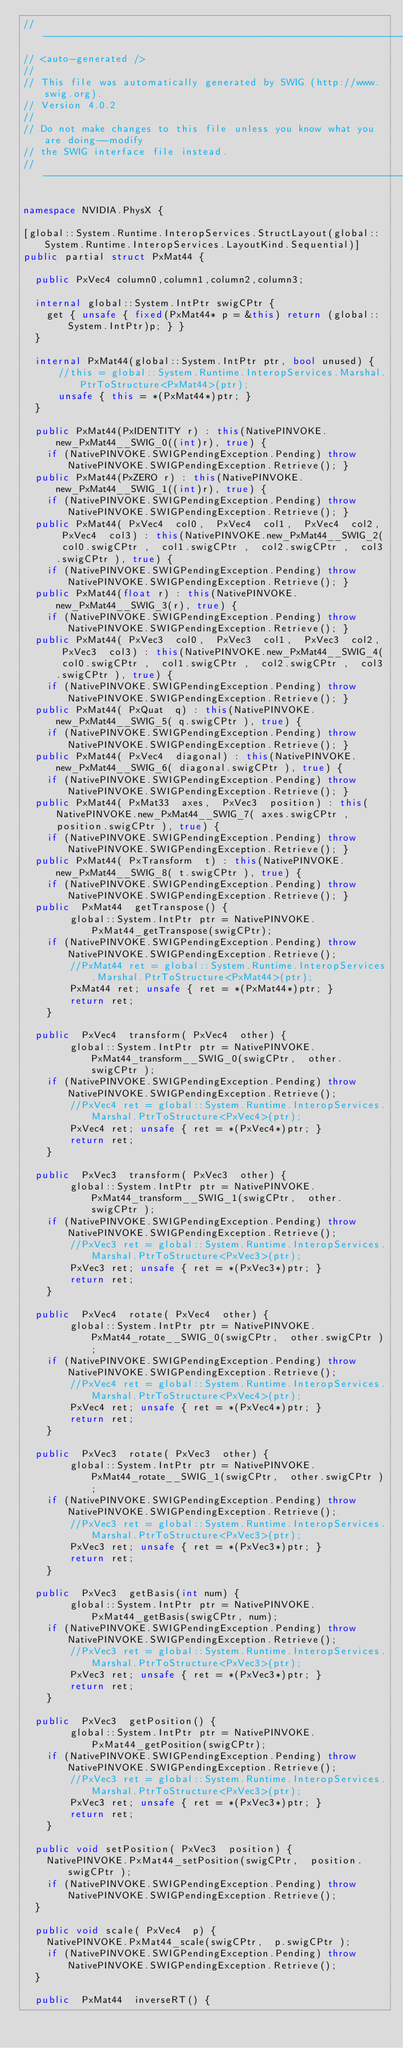<code> <loc_0><loc_0><loc_500><loc_500><_C#_>//------------------------------------------------------------------------------
// <auto-generated />
//
// This file was automatically generated by SWIG (http://www.swig.org).
// Version 4.0.2
//
// Do not make changes to this file unless you know what you are doing--modify
// the SWIG interface file instead.
//------------------------------------------------------------------------------

namespace NVIDIA.PhysX {

[global::System.Runtime.InteropServices.StructLayout(global::System.Runtime.InteropServices.LayoutKind.Sequential)]
public partial struct PxMat44 {

  public PxVec4 column0,column1,column2,column3;

  internal global::System.IntPtr swigCPtr {
    get { unsafe { fixed(PxMat44* p = &this) return (global::System.IntPtr)p; } }
  }

  internal PxMat44(global::System.IntPtr ptr, bool unused) {
      //this = global::System.Runtime.InteropServices.Marshal.PtrToStructure<PxMat44>(ptr);
      unsafe { this = *(PxMat44*)ptr; }
  }
    
  public PxMat44(PxIDENTITY r) : this(NativePINVOKE.new_PxMat44__SWIG_0((int)r), true) { 
    if (NativePINVOKE.SWIGPendingException.Pending) throw NativePINVOKE.SWIGPendingException.Retrieve(); }
  public PxMat44(PxZERO r) : this(NativePINVOKE.new_PxMat44__SWIG_1((int)r), true) { 
    if (NativePINVOKE.SWIGPendingException.Pending) throw NativePINVOKE.SWIGPendingException.Retrieve(); }
  public PxMat44( PxVec4  col0,  PxVec4  col1,  PxVec4  col2,  PxVec4  col3) : this(NativePINVOKE.new_PxMat44__SWIG_2( col0.swigCPtr ,  col1.swigCPtr ,  col2.swigCPtr ,  col3.swigCPtr ), true) { 
    if (NativePINVOKE.SWIGPendingException.Pending) throw NativePINVOKE.SWIGPendingException.Retrieve(); }
  public PxMat44(float r) : this(NativePINVOKE.new_PxMat44__SWIG_3(r), true) { 
    if (NativePINVOKE.SWIGPendingException.Pending) throw NativePINVOKE.SWIGPendingException.Retrieve(); }
  public PxMat44( PxVec3  col0,  PxVec3  col1,  PxVec3  col2,  PxVec3  col3) : this(NativePINVOKE.new_PxMat44__SWIG_4( col0.swigCPtr ,  col1.swigCPtr ,  col2.swigCPtr ,  col3.swigCPtr ), true) { 
    if (NativePINVOKE.SWIGPendingException.Pending) throw NativePINVOKE.SWIGPendingException.Retrieve(); }
  public PxMat44( PxQuat  q) : this(NativePINVOKE.new_PxMat44__SWIG_5( q.swigCPtr ), true) { 
    if (NativePINVOKE.SWIGPendingException.Pending) throw NativePINVOKE.SWIGPendingException.Retrieve(); }
  public PxMat44( PxVec4  diagonal) : this(NativePINVOKE.new_PxMat44__SWIG_6( diagonal.swigCPtr ), true) { 
    if (NativePINVOKE.SWIGPendingException.Pending) throw NativePINVOKE.SWIGPendingException.Retrieve(); }
  public PxMat44( PxMat33  axes,  PxVec3  position) : this(NativePINVOKE.new_PxMat44__SWIG_7( axes.swigCPtr ,  position.swigCPtr ), true) { 
    if (NativePINVOKE.SWIGPendingException.Pending) throw NativePINVOKE.SWIGPendingException.Retrieve(); }
  public PxMat44( PxTransform  t) : this(NativePINVOKE.new_PxMat44__SWIG_8( t.swigCPtr ), true) { 
    if (NativePINVOKE.SWIGPendingException.Pending) throw NativePINVOKE.SWIGPendingException.Retrieve(); }
  public  PxMat44  getTranspose() {
        global::System.IntPtr ptr = NativePINVOKE.PxMat44_getTranspose(swigCPtr);
    if (NativePINVOKE.SWIGPendingException.Pending) throw NativePINVOKE.SWIGPendingException.Retrieve();
        //PxMat44 ret = global::System.Runtime.InteropServices.Marshal.PtrToStructure<PxMat44>(ptr);
        PxMat44 ret; unsafe { ret = *(PxMat44*)ptr; }
        return ret;
    }

  public  PxVec4  transform( PxVec4  other) {
        global::System.IntPtr ptr = NativePINVOKE.PxMat44_transform__SWIG_0(swigCPtr,  other.swigCPtr );
    if (NativePINVOKE.SWIGPendingException.Pending) throw NativePINVOKE.SWIGPendingException.Retrieve();
        //PxVec4 ret = global::System.Runtime.InteropServices.Marshal.PtrToStructure<PxVec4>(ptr);
        PxVec4 ret; unsafe { ret = *(PxVec4*)ptr; }
        return ret;
    }

  public  PxVec3  transform( PxVec3  other) {
        global::System.IntPtr ptr = NativePINVOKE.PxMat44_transform__SWIG_1(swigCPtr,  other.swigCPtr );
    if (NativePINVOKE.SWIGPendingException.Pending) throw NativePINVOKE.SWIGPendingException.Retrieve();
        //PxVec3 ret = global::System.Runtime.InteropServices.Marshal.PtrToStructure<PxVec3>(ptr);
        PxVec3 ret; unsafe { ret = *(PxVec3*)ptr; }
        return ret;
    }

  public  PxVec4  rotate( PxVec4  other) {
        global::System.IntPtr ptr = NativePINVOKE.PxMat44_rotate__SWIG_0(swigCPtr,  other.swigCPtr );
    if (NativePINVOKE.SWIGPendingException.Pending) throw NativePINVOKE.SWIGPendingException.Retrieve();
        //PxVec4 ret = global::System.Runtime.InteropServices.Marshal.PtrToStructure<PxVec4>(ptr);
        PxVec4 ret; unsafe { ret = *(PxVec4*)ptr; }
        return ret;
    }

  public  PxVec3  rotate( PxVec3  other) {
        global::System.IntPtr ptr = NativePINVOKE.PxMat44_rotate__SWIG_1(swigCPtr,  other.swigCPtr );
    if (NativePINVOKE.SWIGPendingException.Pending) throw NativePINVOKE.SWIGPendingException.Retrieve();
        //PxVec3 ret = global::System.Runtime.InteropServices.Marshal.PtrToStructure<PxVec3>(ptr);
        PxVec3 ret; unsafe { ret = *(PxVec3*)ptr; }
        return ret;
    }

  public  PxVec3  getBasis(int num) {
        global::System.IntPtr ptr = NativePINVOKE.PxMat44_getBasis(swigCPtr, num);
    if (NativePINVOKE.SWIGPendingException.Pending) throw NativePINVOKE.SWIGPendingException.Retrieve();
        //PxVec3 ret = global::System.Runtime.InteropServices.Marshal.PtrToStructure<PxVec3>(ptr);
        PxVec3 ret; unsafe { ret = *(PxVec3*)ptr; }
        return ret;
    }

  public  PxVec3  getPosition() {
        global::System.IntPtr ptr = NativePINVOKE.PxMat44_getPosition(swigCPtr);
    if (NativePINVOKE.SWIGPendingException.Pending) throw NativePINVOKE.SWIGPendingException.Retrieve();
        //PxVec3 ret = global::System.Runtime.InteropServices.Marshal.PtrToStructure<PxVec3>(ptr);
        PxVec3 ret; unsafe { ret = *(PxVec3*)ptr; }
        return ret;
    }

  public void setPosition( PxVec3  position) {
    NativePINVOKE.PxMat44_setPosition(swigCPtr,  position.swigCPtr );
    if (NativePINVOKE.SWIGPendingException.Pending) throw NativePINVOKE.SWIGPendingException.Retrieve();
  }

  public void scale( PxVec4  p) {
    NativePINVOKE.PxMat44_scale(swigCPtr,  p.swigCPtr );
    if (NativePINVOKE.SWIGPendingException.Pending) throw NativePINVOKE.SWIGPendingException.Retrieve();
  }

  public  PxMat44  inverseRT() {</code> 